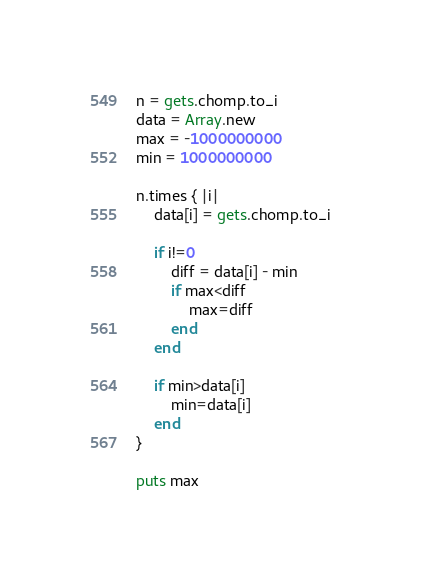Convert code to text. <code><loc_0><loc_0><loc_500><loc_500><_Ruby_>n = gets.chomp.to_i
data = Array.new
max = -1000000000
min = 1000000000

n.times { |i|
	data[i] = gets.chomp.to_i
	
	if i!=0
		diff = data[i] - min
		if max<diff
			max=diff
		end
	end
	
	if min>data[i]
		min=data[i]
	end
}

puts max</code> 